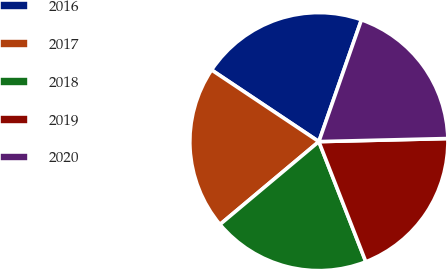<chart> <loc_0><loc_0><loc_500><loc_500><pie_chart><fcel>2016<fcel>2017<fcel>2018<fcel>2019<fcel>2020<nl><fcel>20.98%<fcel>20.47%<fcel>19.83%<fcel>19.45%<fcel>19.27%<nl></chart> 